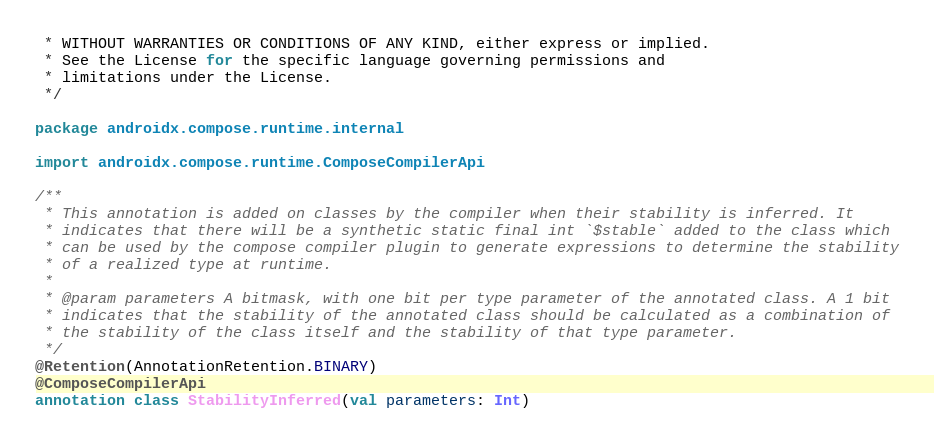Convert code to text. <code><loc_0><loc_0><loc_500><loc_500><_Kotlin_> * WITHOUT WARRANTIES OR CONDITIONS OF ANY KIND, either express or implied.
 * See the License for the specific language governing permissions and
 * limitations under the License.
 */

package androidx.compose.runtime.internal

import androidx.compose.runtime.ComposeCompilerApi

/**
 * This annotation is added on classes by the compiler when their stability is inferred. It
 * indicates that there will be a synthetic static final int `$stable` added to the class which
 * can be used by the compose compiler plugin to generate expressions to determine the stability
 * of a realized type at runtime.
 *
 * @param parameters A bitmask, with one bit per type parameter of the annotated class. A 1 bit
 * indicates that the stability of the annotated class should be calculated as a combination of
 * the stability of the class itself and the stability of that type parameter.
 */
@Retention(AnnotationRetention.BINARY)
@ComposeCompilerApi
annotation class StabilityInferred(val parameters: Int)
</code> 